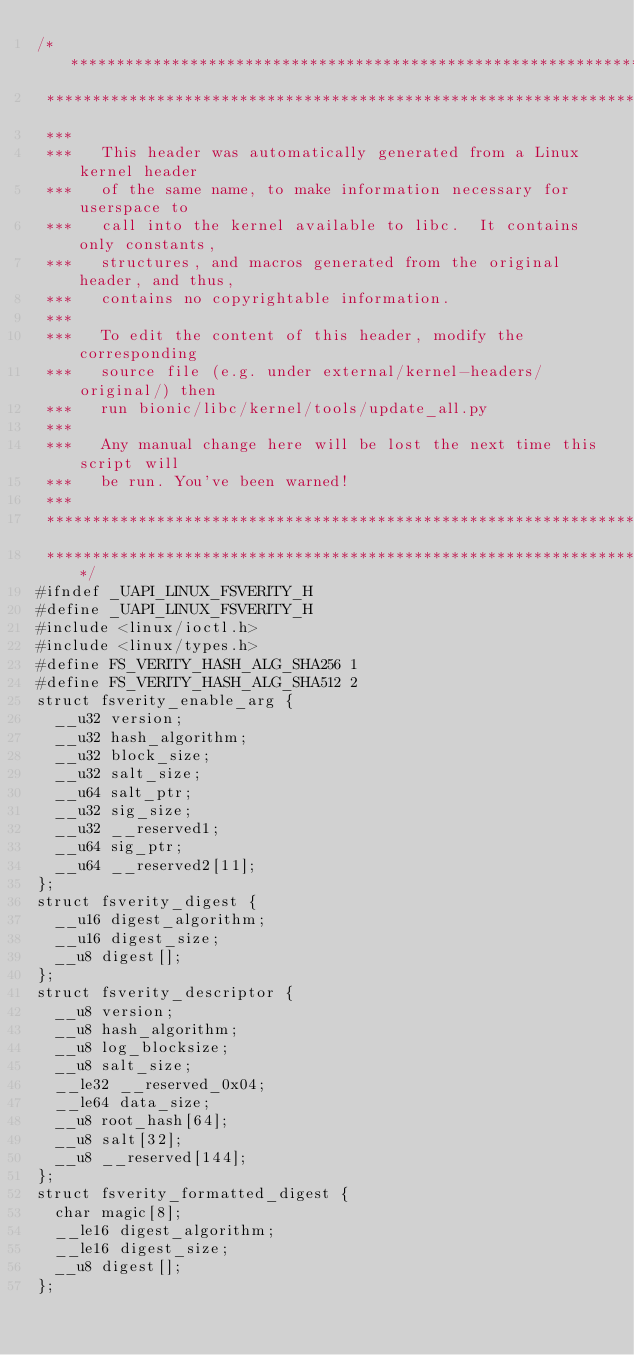<code> <loc_0><loc_0><loc_500><loc_500><_C_>/****************************************************************************
 ****************************************************************************
 ***
 ***   This header was automatically generated from a Linux kernel header
 ***   of the same name, to make information necessary for userspace to
 ***   call into the kernel available to libc.  It contains only constants,
 ***   structures, and macros generated from the original header, and thus,
 ***   contains no copyrightable information.
 ***
 ***   To edit the content of this header, modify the corresponding
 ***   source file (e.g. under external/kernel-headers/original/) then
 ***   run bionic/libc/kernel/tools/update_all.py
 ***
 ***   Any manual change here will be lost the next time this script will
 ***   be run. You've been warned!
 ***
 ****************************************************************************
 ****************************************************************************/
#ifndef _UAPI_LINUX_FSVERITY_H
#define _UAPI_LINUX_FSVERITY_H
#include <linux/ioctl.h>
#include <linux/types.h>
#define FS_VERITY_HASH_ALG_SHA256 1
#define FS_VERITY_HASH_ALG_SHA512 2
struct fsverity_enable_arg {
  __u32 version;
  __u32 hash_algorithm;
  __u32 block_size;
  __u32 salt_size;
  __u64 salt_ptr;
  __u32 sig_size;
  __u32 __reserved1;
  __u64 sig_ptr;
  __u64 __reserved2[11];
};
struct fsverity_digest {
  __u16 digest_algorithm;
  __u16 digest_size;
  __u8 digest[];
};
struct fsverity_descriptor {
  __u8 version;
  __u8 hash_algorithm;
  __u8 log_blocksize;
  __u8 salt_size;
  __le32 __reserved_0x04;
  __le64 data_size;
  __u8 root_hash[64];
  __u8 salt[32];
  __u8 __reserved[144];
};
struct fsverity_formatted_digest {
  char magic[8];
  __le16 digest_algorithm;
  __le16 digest_size;
  __u8 digest[];
};</code> 